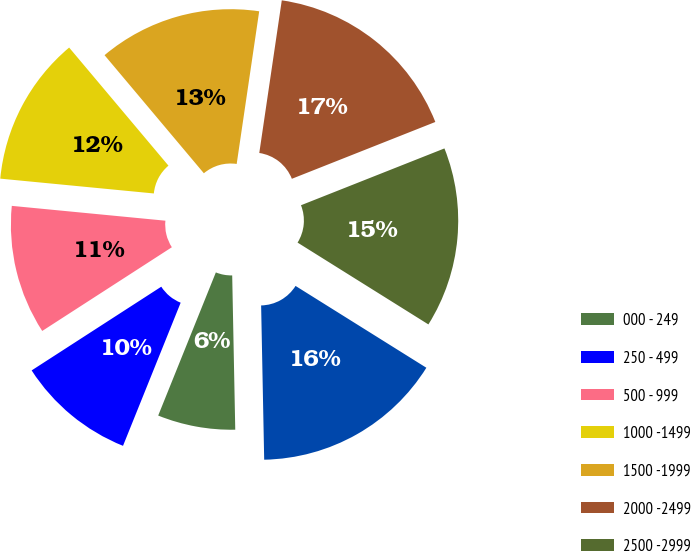Convert chart to OTSL. <chart><loc_0><loc_0><loc_500><loc_500><pie_chart><fcel>000 - 249<fcel>250 - 499<fcel>500 - 999<fcel>1000 -1499<fcel>1500 -1999<fcel>2000 -2499<fcel>2500 -2999<fcel>3000 -3499<nl><fcel>6.41%<fcel>9.78%<fcel>10.66%<fcel>12.34%<fcel>13.46%<fcel>16.67%<fcel>14.9%<fcel>15.79%<nl></chart> 